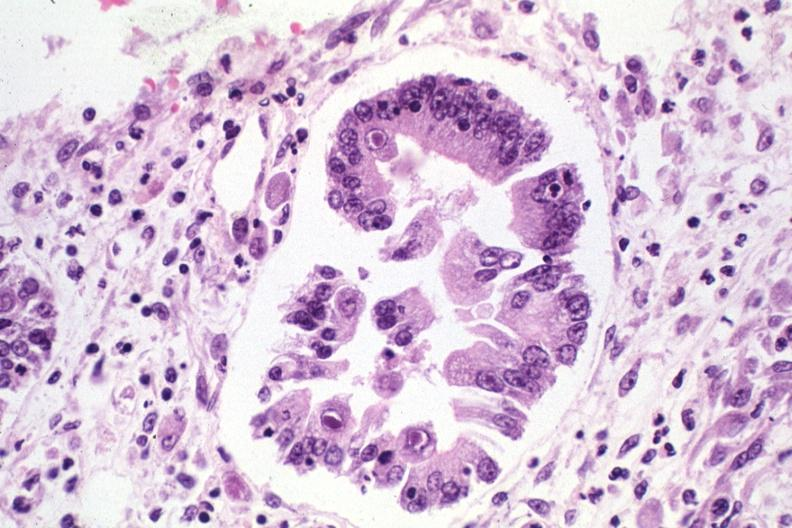s antitrypsin present?
Answer the question using a single word or phrase. No 